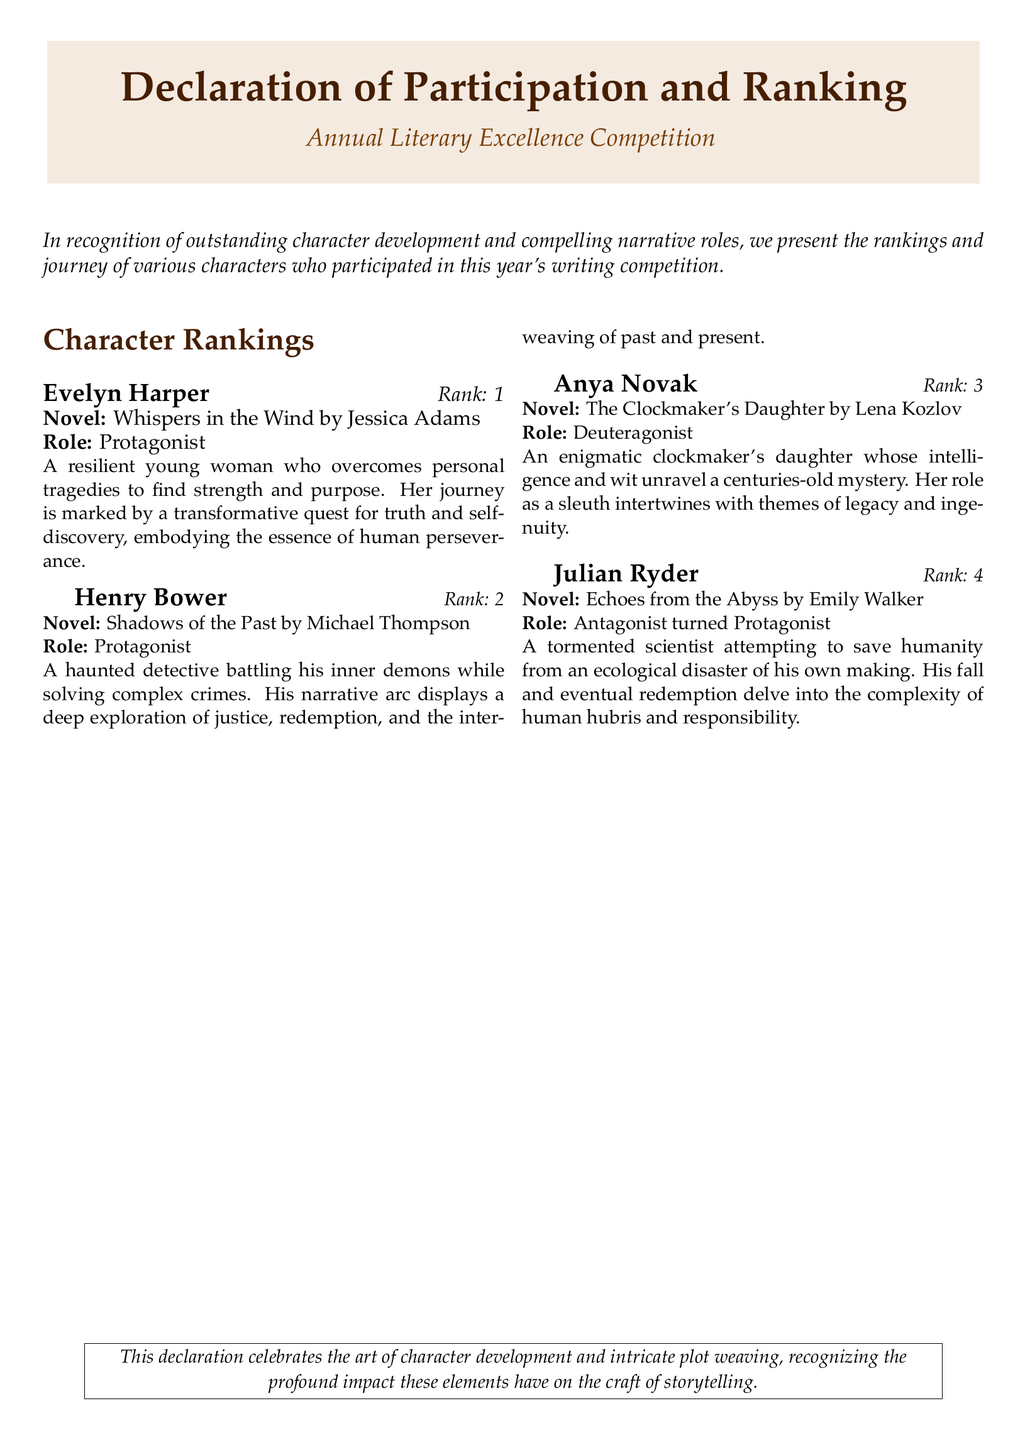What is the title of the competition? The title of the competition is explicitly stated at the top of the document.
Answer: Annual Literary Excellence Competition Who ranked third in the competition? The document lists the character rankings clearly, specifying the order.
Answer: Anya Novak Which character is identified as the protagonist? The document highlights characters and their roles, with "Protagonist" being a specific role listed.
Answer: Evelyn Harper What is the role of Julian Ryder? The document details the roles each character plays in their respective narratives.
Answer: Antagonist turned Protagonist How many characters are mentioned in the rankings? The document provides a specific list of characters and their ranks.
Answer: Four What novel did Henry Bower appear in? The document includes the names of novels associated with each character.
Answer: Shadows of the Past Which character's journey involves themes of legacy and ingenuity? The document gives a brief overview of each character, focusing on their narrative themes.
Answer: Anya Novak What is the rank of Evelyn Harper? The document specifies character rankings directly associated with each character.
Answer: 1 